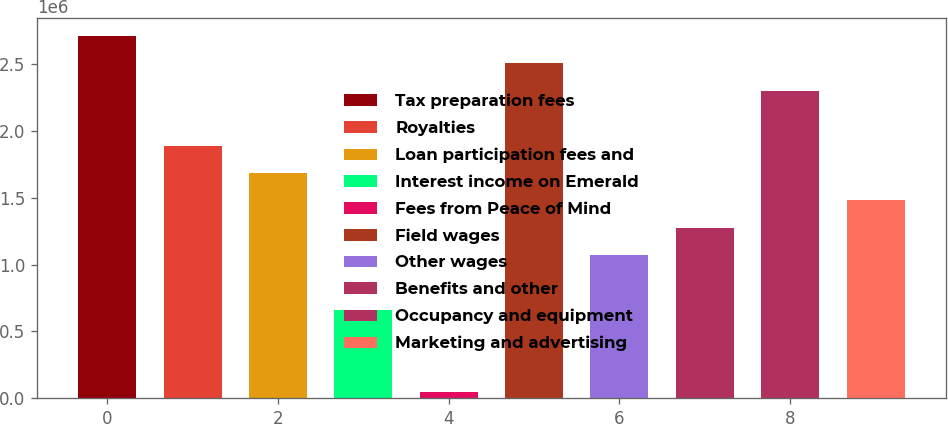<chart> <loc_0><loc_0><loc_500><loc_500><bar_chart><fcel>Tax preparation fees<fcel>Royalties<fcel>Loan participation fees and<fcel>Interest income on Emerald<fcel>Fees from Peace of Mind<fcel>Field wages<fcel>Other wages<fcel>Benefits and other<fcel>Occupancy and equipment<fcel>Marketing and advertising<nl><fcel>2.71151e+06<fcel>1.89115e+06<fcel>1.68606e+06<fcel>660608<fcel>45339<fcel>2.50642e+06<fcel>1.07079e+06<fcel>1.27588e+06<fcel>2.30133e+06<fcel>1.48097e+06<nl></chart> 